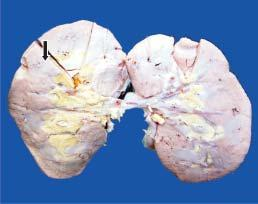s the kidney small and pale in colour?
Answer the question using a single word or phrase. Yes 